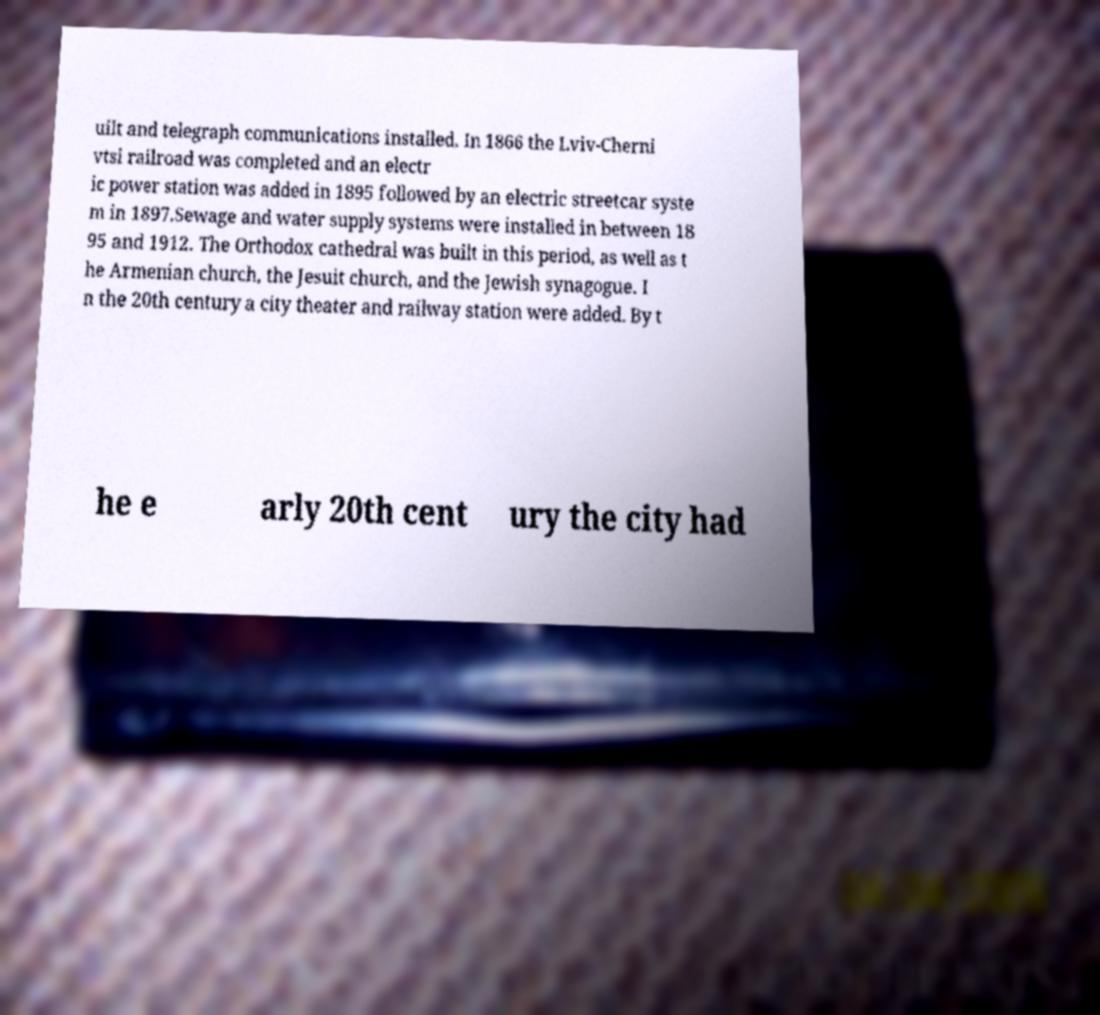I need the written content from this picture converted into text. Can you do that? uilt and telegraph communications installed. In 1866 the Lviv-Cherni vtsi railroad was completed and an electr ic power station was added in 1895 followed by an electric streetcar syste m in 1897.Sewage and water supply systems were installed in between 18 95 and 1912. The Orthodox cathedral was built in this period, as well as t he Armenian church, the Jesuit church, and the Jewish synagogue. I n the 20th century a city theater and railway station were added. By t he e arly 20th cent ury the city had 